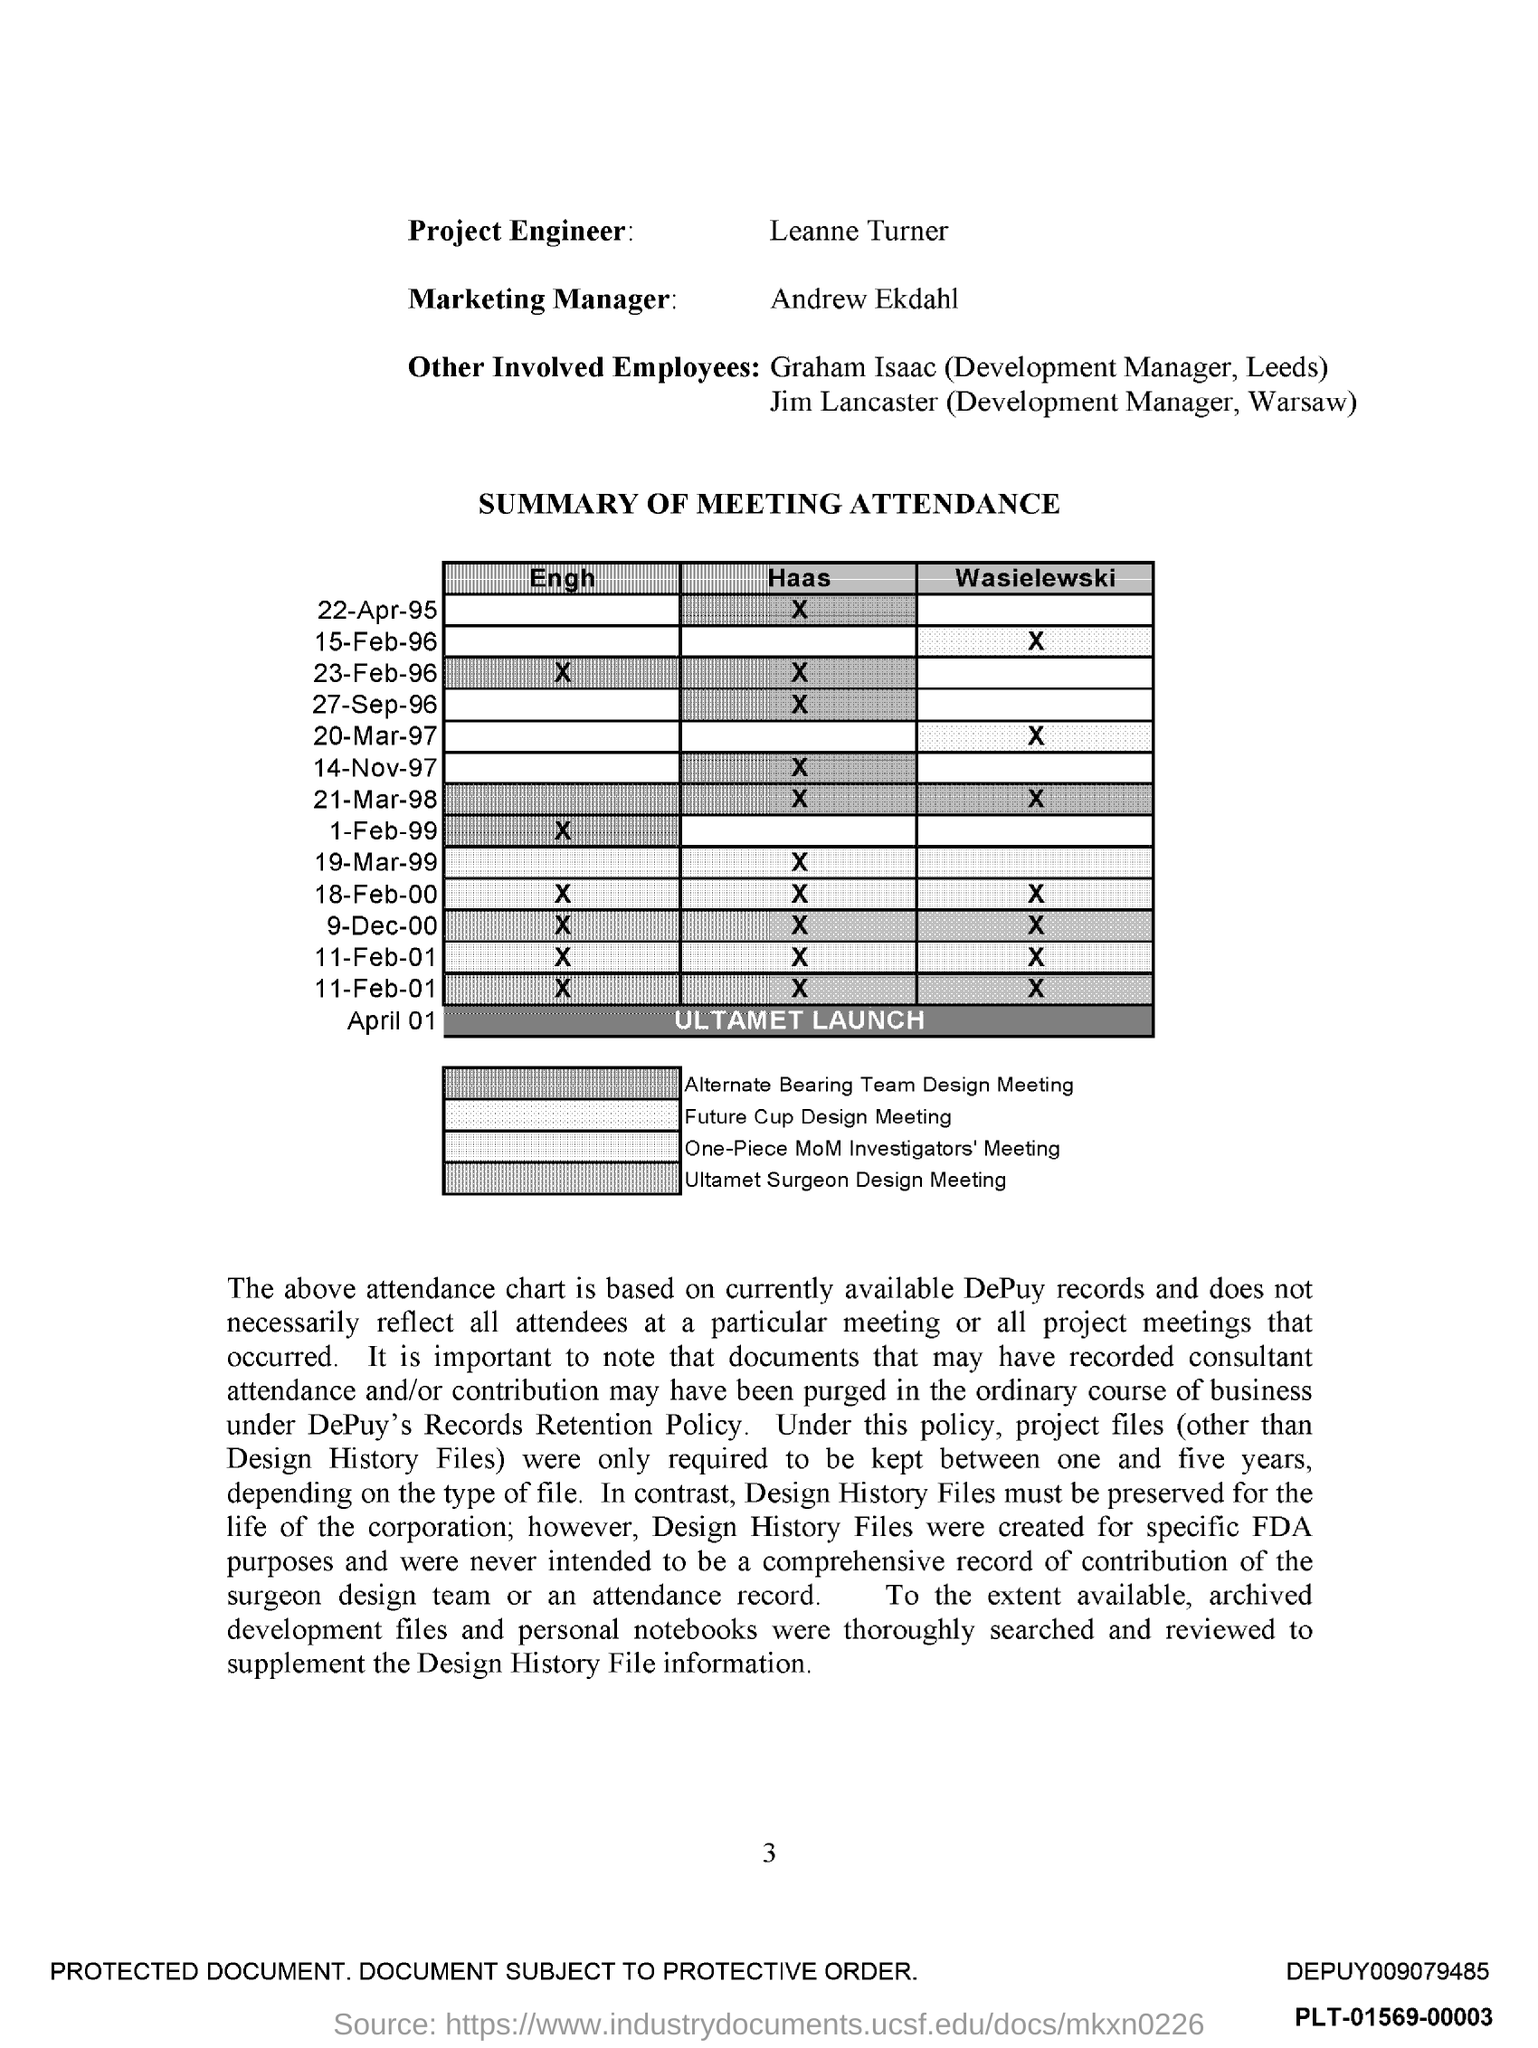Point out several critical features in this image. The person named Leanne Turner is the project engineer. The marketing manager's name is Andrew Ekdahl. 